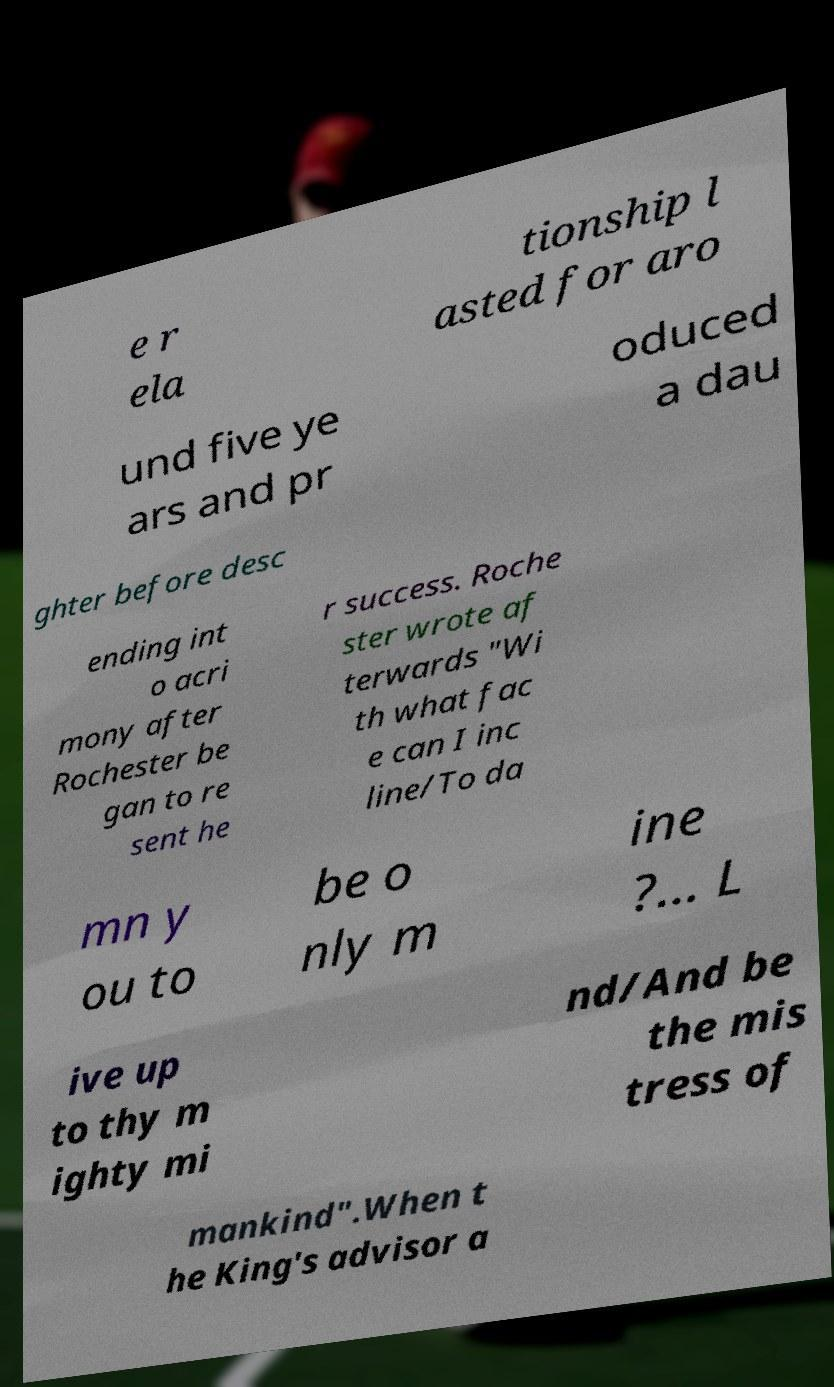I need the written content from this picture converted into text. Can you do that? e r ela tionship l asted for aro und five ye ars and pr oduced a dau ghter before desc ending int o acri mony after Rochester be gan to re sent he r success. Roche ster wrote af terwards "Wi th what fac e can I inc line/To da mn y ou to be o nly m ine ?… L ive up to thy m ighty mi nd/And be the mis tress of mankind".When t he King's advisor a 